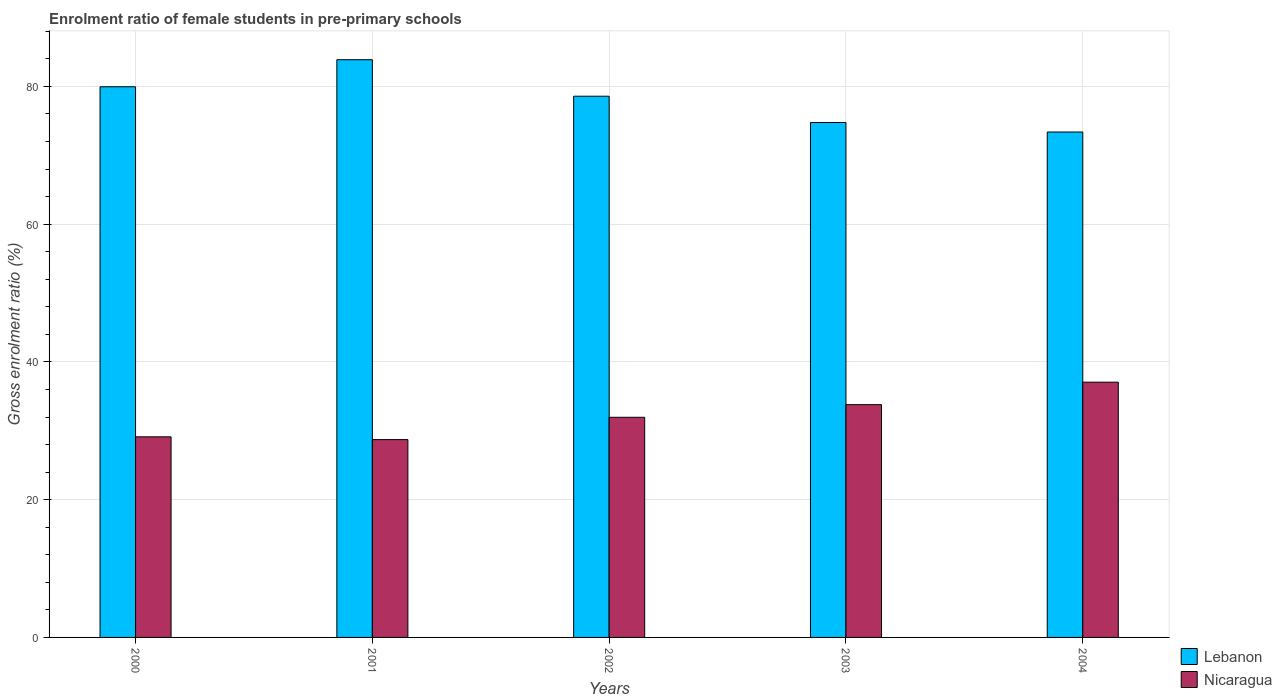Are the number of bars per tick equal to the number of legend labels?
Your answer should be compact. Yes. Are the number of bars on each tick of the X-axis equal?
Offer a very short reply. Yes. What is the label of the 1st group of bars from the left?
Give a very brief answer. 2000. What is the enrolment ratio of female students in pre-primary schools in Lebanon in 2003?
Offer a very short reply. 74.76. Across all years, what is the maximum enrolment ratio of female students in pre-primary schools in Lebanon?
Offer a very short reply. 83.88. Across all years, what is the minimum enrolment ratio of female students in pre-primary schools in Lebanon?
Provide a succinct answer. 73.38. In which year was the enrolment ratio of female students in pre-primary schools in Lebanon maximum?
Keep it short and to the point. 2001. What is the total enrolment ratio of female students in pre-primary schools in Lebanon in the graph?
Your answer should be compact. 390.55. What is the difference between the enrolment ratio of female students in pre-primary schools in Lebanon in 2002 and that in 2004?
Ensure brevity in your answer.  5.2. What is the difference between the enrolment ratio of female students in pre-primary schools in Lebanon in 2002 and the enrolment ratio of female students in pre-primary schools in Nicaragua in 2004?
Give a very brief answer. 41.52. What is the average enrolment ratio of female students in pre-primary schools in Lebanon per year?
Provide a short and direct response. 78.11. In the year 2002, what is the difference between the enrolment ratio of female students in pre-primary schools in Lebanon and enrolment ratio of female students in pre-primary schools in Nicaragua?
Offer a terse response. 46.62. What is the ratio of the enrolment ratio of female students in pre-primary schools in Nicaragua in 2000 to that in 2002?
Provide a short and direct response. 0.91. Is the difference between the enrolment ratio of female students in pre-primary schools in Lebanon in 2000 and 2003 greater than the difference between the enrolment ratio of female students in pre-primary schools in Nicaragua in 2000 and 2003?
Your answer should be very brief. Yes. What is the difference between the highest and the second highest enrolment ratio of female students in pre-primary schools in Lebanon?
Your answer should be compact. 3.93. What is the difference between the highest and the lowest enrolment ratio of female students in pre-primary schools in Nicaragua?
Give a very brief answer. 8.34. In how many years, is the enrolment ratio of female students in pre-primary schools in Lebanon greater than the average enrolment ratio of female students in pre-primary schools in Lebanon taken over all years?
Keep it short and to the point. 3. What does the 2nd bar from the left in 2001 represents?
Your answer should be compact. Nicaragua. What does the 1st bar from the right in 2001 represents?
Your answer should be very brief. Nicaragua. Are all the bars in the graph horizontal?
Offer a terse response. No. Are the values on the major ticks of Y-axis written in scientific E-notation?
Your answer should be compact. No. Does the graph contain any zero values?
Offer a terse response. No. Does the graph contain grids?
Your answer should be very brief. Yes. How many legend labels are there?
Provide a succinct answer. 2. What is the title of the graph?
Provide a short and direct response. Enrolment ratio of female students in pre-primary schools. Does "Europe(developing only)" appear as one of the legend labels in the graph?
Provide a short and direct response. No. What is the label or title of the Y-axis?
Offer a very short reply. Gross enrolment ratio (%). What is the Gross enrolment ratio (%) of Lebanon in 2000?
Your answer should be compact. 79.95. What is the Gross enrolment ratio (%) in Nicaragua in 2000?
Provide a succinct answer. 29.13. What is the Gross enrolment ratio (%) of Lebanon in 2001?
Keep it short and to the point. 83.88. What is the Gross enrolment ratio (%) of Nicaragua in 2001?
Offer a very short reply. 28.72. What is the Gross enrolment ratio (%) of Lebanon in 2002?
Your answer should be compact. 78.58. What is the Gross enrolment ratio (%) of Nicaragua in 2002?
Your response must be concise. 31.96. What is the Gross enrolment ratio (%) in Lebanon in 2003?
Your answer should be very brief. 74.76. What is the Gross enrolment ratio (%) of Nicaragua in 2003?
Provide a short and direct response. 33.8. What is the Gross enrolment ratio (%) in Lebanon in 2004?
Make the answer very short. 73.38. What is the Gross enrolment ratio (%) in Nicaragua in 2004?
Your response must be concise. 37.06. Across all years, what is the maximum Gross enrolment ratio (%) of Lebanon?
Your answer should be compact. 83.88. Across all years, what is the maximum Gross enrolment ratio (%) of Nicaragua?
Keep it short and to the point. 37.06. Across all years, what is the minimum Gross enrolment ratio (%) of Lebanon?
Your answer should be compact. 73.38. Across all years, what is the minimum Gross enrolment ratio (%) in Nicaragua?
Give a very brief answer. 28.72. What is the total Gross enrolment ratio (%) of Lebanon in the graph?
Offer a terse response. 390.55. What is the total Gross enrolment ratio (%) of Nicaragua in the graph?
Provide a succinct answer. 160.67. What is the difference between the Gross enrolment ratio (%) of Lebanon in 2000 and that in 2001?
Your answer should be compact. -3.93. What is the difference between the Gross enrolment ratio (%) in Nicaragua in 2000 and that in 2001?
Make the answer very short. 0.41. What is the difference between the Gross enrolment ratio (%) in Lebanon in 2000 and that in 2002?
Give a very brief answer. 1.37. What is the difference between the Gross enrolment ratio (%) of Nicaragua in 2000 and that in 2002?
Provide a short and direct response. -2.83. What is the difference between the Gross enrolment ratio (%) of Lebanon in 2000 and that in 2003?
Offer a terse response. 5.19. What is the difference between the Gross enrolment ratio (%) of Nicaragua in 2000 and that in 2003?
Provide a succinct answer. -4.67. What is the difference between the Gross enrolment ratio (%) of Lebanon in 2000 and that in 2004?
Your response must be concise. 6.57. What is the difference between the Gross enrolment ratio (%) of Nicaragua in 2000 and that in 2004?
Make the answer very short. -7.93. What is the difference between the Gross enrolment ratio (%) in Lebanon in 2001 and that in 2002?
Your response must be concise. 5.3. What is the difference between the Gross enrolment ratio (%) in Nicaragua in 2001 and that in 2002?
Offer a terse response. -3.24. What is the difference between the Gross enrolment ratio (%) in Lebanon in 2001 and that in 2003?
Offer a very short reply. 9.12. What is the difference between the Gross enrolment ratio (%) of Nicaragua in 2001 and that in 2003?
Provide a short and direct response. -5.08. What is the difference between the Gross enrolment ratio (%) in Lebanon in 2001 and that in 2004?
Ensure brevity in your answer.  10.5. What is the difference between the Gross enrolment ratio (%) in Nicaragua in 2001 and that in 2004?
Ensure brevity in your answer.  -8.34. What is the difference between the Gross enrolment ratio (%) in Lebanon in 2002 and that in 2003?
Your answer should be very brief. 3.82. What is the difference between the Gross enrolment ratio (%) of Nicaragua in 2002 and that in 2003?
Your response must be concise. -1.84. What is the difference between the Gross enrolment ratio (%) in Lebanon in 2002 and that in 2004?
Give a very brief answer. 5.2. What is the difference between the Gross enrolment ratio (%) in Nicaragua in 2002 and that in 2004?
Offer a very short reply. -5.1. What is the difference between the Gross enrolment ratio (%) in Lebanon in 2003 and that in 2004?
Offer a very short reply. 1.38. What is the difference between the Gross enrolment ratio (%) in Nicaragua in 2003 and that in 2004?
Your answer should be compact. -3.26. What is the difference between the Gross enrolment ratio (%) in Lebanon in 2000 and the Gross enrolment ratio (%) in Nicaragua in 2001?
Offer a terse response. 51.23. What is the difference between the Gross enrolment ratio (%) in Lebanon in 2000 and the Gross enrolment ratio (%) in Nicaragua in 2002?
Give a very brief answer. 47.99. What is the difference between the Gross enrolment ratio (%) of Lebanon in 2000 and the Gross enrolment ratio (%) of Nicaragua in 2003?
Your answer should be compact. 46.15. What is the difference between the Gross enrolment ratio (%) in Lebanon in 2000 and the Gross enrolment ratio (%) in Nicaragua in 2004?
Offer a very short reply. 42.89. What is the difference between the Gross enrolment ratio (%) in Lebanon in 2001 and the Gross enrolment ratio (%) in Nicaragua in 2002?
Your response must be concise. 51.92. What is the difference between the Gross enrolment ratio (%) of Lebanon in 2001 and the Gross enrolment ratio (%) of Nicaragua in 2003?
Your response must be concise. 50.08. What is the difference between the Gross enrolment ratio (%) of Lebanon in 2001 and the Gross enrolment ratio (%) of Nicaragua in 2004?
Offer a very short reply. 46.82. What is the difference between the Gross enrolment ratio (%) of Lebanon in 2002 and the Gross enrolment ratio (%) of Nicaragua in 2003?
Provide a succinct answer. 44.78. What is the difference between the Gross enrolment ratio (%) of Lebanon in 2002 and the Gross enrolment ratio (%) of Nicaragua in 2004?
Your response must be concise. 41.52. What is the difference between the Gross enrolment ratio (%) in Lebanon in 2003 and the Gross enrolment ratio (%) in Nicaragua in 2004?
Offer a terse response. 37.7. What is the average Gross enrolment ratio (%) in Lebanon per year?
Offer a terse response. 78.11. What is the average Gross enrolment ratio (%) of Nicaragua per year?
Make the answer very short. 32.13. In the year 2000, what is the difference between the Gross enrolment ratio (%) of Lebanon and Gross enrolment ratio (%) of Nicaragua?
Your answer should be very brief. 50.82. In the year 2001, what is the difference between the Gross enrolment ratio (%) in Lebanon and Gross enrolment ratio (%) in Nicaragua?
Offer a terse response. 55.16. In the year 2002, what is the difference between the Gross enrolment ratio (%) in Lebanon and Gross enrolment ratio (%) in Nicaragua?
Your answer should be very brief. 46.62. In the year 2003, what is the difference between the Gross enrolment ratio (%) of Lebanon and Gross enrolment ratio (%) of Nicaragua?
Ensure brevity in your answer.  40.96. In the year 2004, what is the difference between the Gross enrolment ratio (%) in Lebanon and Gross enrolment ratio (%) in Nicaragua?
Your answer should be very brief. 36.32. What is the ratio of the Gross enrolment ratio (%) in Lebanon in 2000 to that in 2001?
Provide a succinct answer. 0.95. What is the ratio of the Gross enrolment ratio (%) of Nicaragua in 2000 to that in 2001?
Provide a short and direct response. 1.01. What is the ratio of the Gross enrolment ratio (%) in Lebanon in 2000 to that in 2002?
Offer a very short reply. 1.02. What is the ratio of the Gross enrolment ratio (%) of Nicaragua in 2000 to that in 2002?
Your response must be concise. 0.91. What is the ratio of the Gross enrolment ratio (%) in Lebanon in 2000 to that in 2003?
Offer a very short reply. 1.07. What is the ratio of the Gross enrolment ratio (%) in Nicaragua in 2000 to that in 2003?
Provide a short and direct response. 0.86. What is the ratio of the Gross enrolment ratio (%) in Lebanon in 2000 to that in 2004?
Provide a short and direct response. 1.09. What is the ratio of the Gross enrolment ratio (%) in Nicaragua in 2000 to that in 2004?
Make the answer very short. 0.79. What is the ratio of the Gross enrolment ratio (%) in Lebanon in 2001 to that in 2002?
Provide a short and direct response. 1.07. What is the ratio of the Gross enrolment ratio (%) in Nicaragua in 2001 to that in 2002?
Give a very brief answer. 0.9. What is the ratio of the Gross enrolment ratio (%) of Lebanon in 2001 to that in 2003?
Give a very brief answer. 1.12. What is the ratio of the Gross enrolment ratio (%) in Nicaragua in 2001 to that in 2003?
Ensure brevity in your answer.  0.85. What is the ratio of the Gross enrolment ratio (%) in Lebanon in 2001 to that in 2004?
Your answer should be compact. 1.14. What is the ratio of the Gross enrolment ratio (%) of Nicaragua in 2001 to that in 2004?
Give a very brief answer. 0.78. What is the ratio of the Gross enrolment ratio (%) of Lebanon in 2002 to that in 2003?
Offer a terse response. 1.05. What is the ratio of the Gross enrolment ratio (%) in Nicaragua in 2002 to that in 2003?
Provide a succinct answer. 0.95. What is the ratio of the Gross enrolment ratio (%) in Lebanon in 2002 to that in 2004?
Your answer should be very brief. 1.07. What is the ratio of the Gross enrolment ratio (%) of Nicaragua in 2002 to that in 2004?
Make the answer very short. 0.86. What is the ratio of the Gross enrolment ratio (%) in Lebanon in 2003 to that in 2004?
Offer a very short reply. 1.02. What is the ratio of the Gross enrolment ratio (%) in Nicaragua in 2003 to that in 2004?
Offer a terse response. 0.91. What is the difference between the highest and the second highest Gross enrolment ratio (%) of Lebanon?
Your answer should be very brief. 3.93. What is the difference between the highest and the second highest Gross enrolment ratio (%) of Nicaragua?
Your answer should be very brief. 3.26. What is the difference between the highest and the lowest Gross enrolment ratio (%) of Lebanon?
Offer a terse response. 10.5. What is the difference between the highest and the lowest Gross enrolment ratio (%) of Nicaragua?
Give a very brief answer. 8.34. 